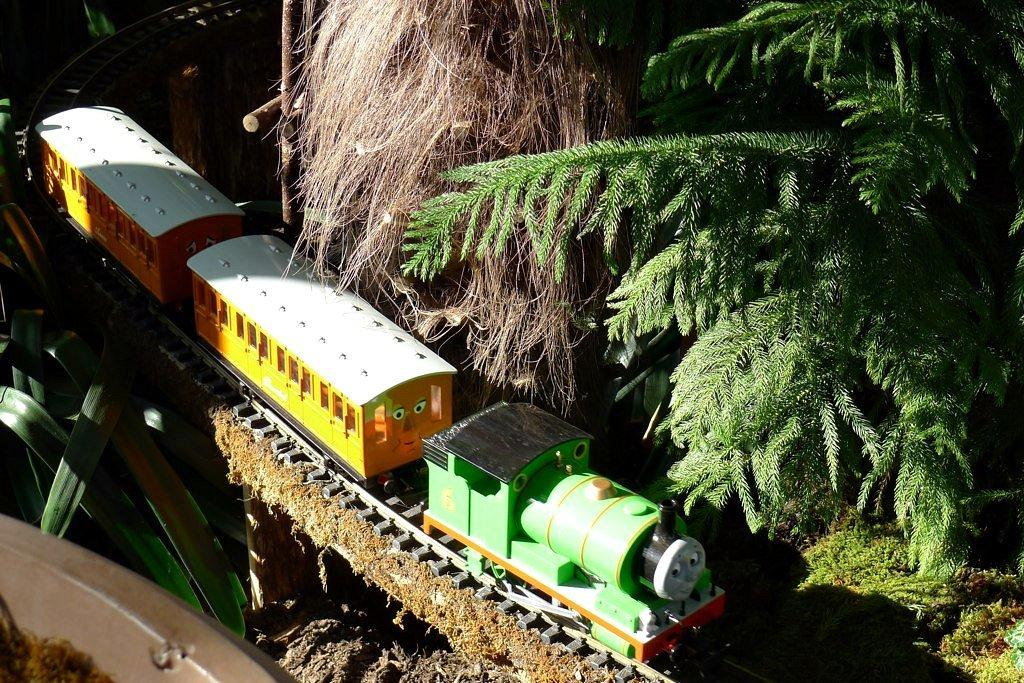What type of natural elements can be seen in the image? There are trees in the image. What colors are the trees in the image? The trees are green and brown in color. What man-made object is present in the image? There is a toy train in the image. What colors are the toy train in the image? The toy train is green, black, yellow, and white in color. How is the toy train positioned in the image? The toy train is on a track. How many pets are visible in the image? There are no pets present in the image. What type of humor can be seen in the image? There is no humor depicted in the image; it features trees and a toy train on a track. 